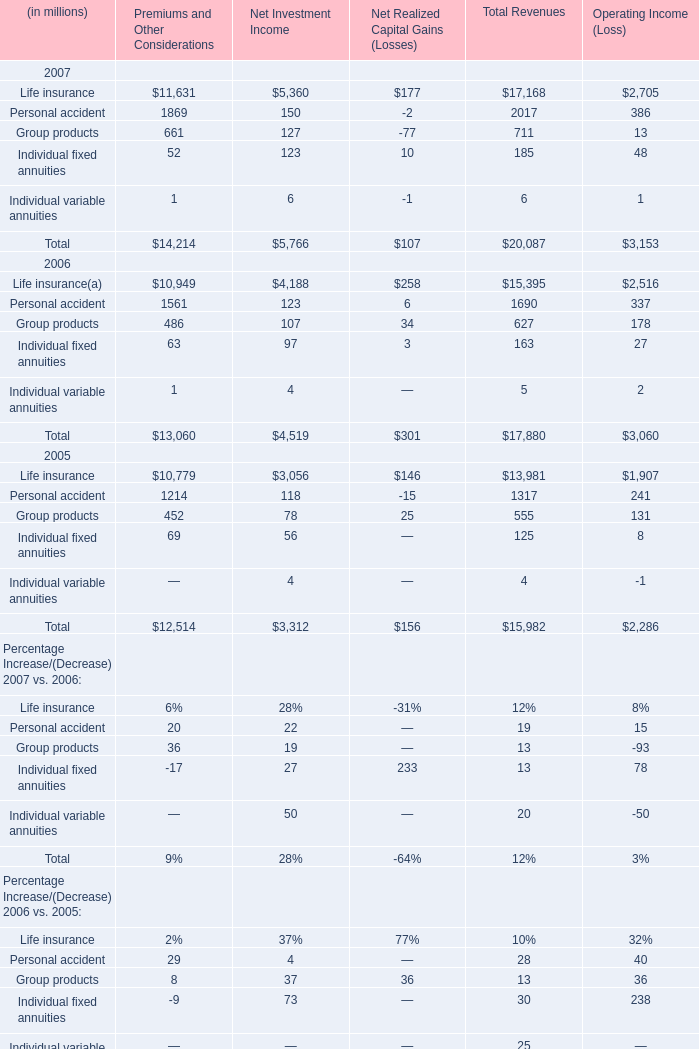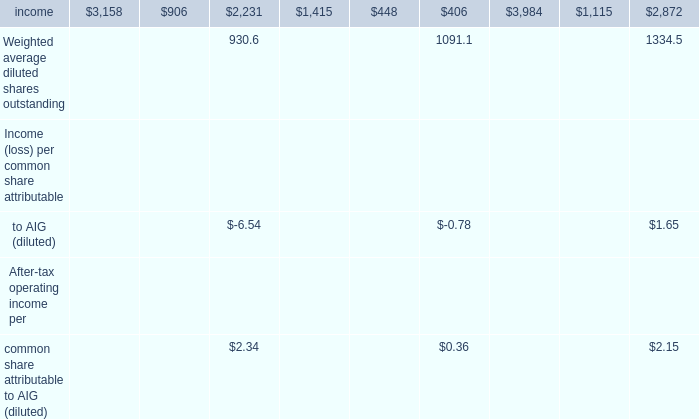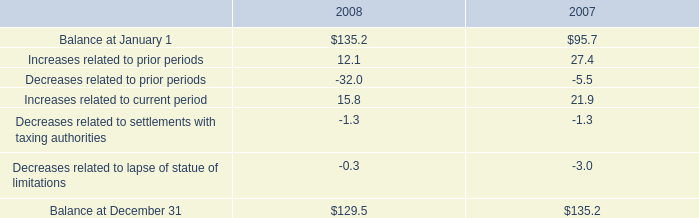How many Premiums and Other Considerations keeps increasing each year between 2005 and 2007? 
Answer: 5. 